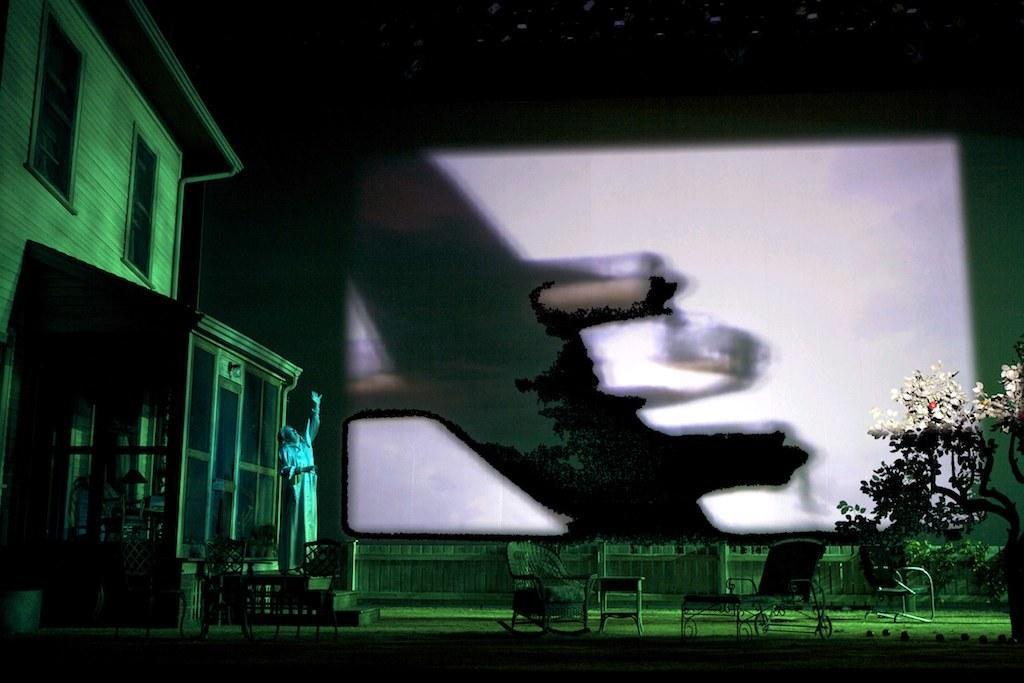How would you summarize this image in a sentence or two? In this image we can see a building, chairs, tree, and a person. In the background we can see a screen. 